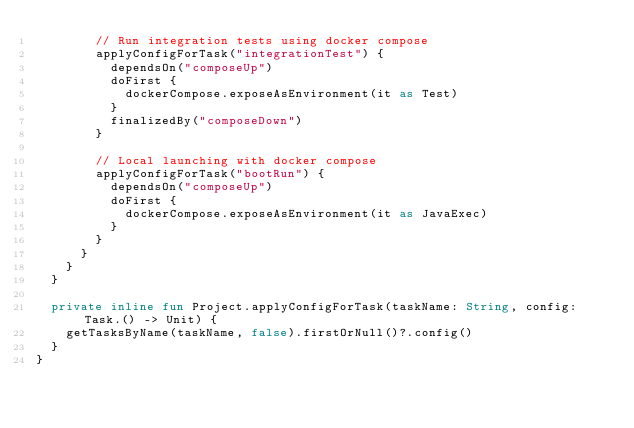Convert code to text. <code><loc_0><loc_0><loc_500><loc_500><_Kotlin_>        // Run integration tests using docker compose
        applyConfigForTask("integrationTest") {
          dependsOn("composeUp")
          doFirst {
            dockerCompose.exposeAsEnvironment(it as Test)
          }
          finalizedBy("composeDown")
        }

        // Local launching with docker compose
        applyConfigForTask("bootRun") {
          dependsOn("composeUp")
          doFirst {
            dockerCompose.exposeAsEnvironment(it as JavaExec)
          }
        }
      }
    }
  }

  private inline fun Project.applyConfigForTask(taskName: String, config: Task.() -> Unit) {
    getTasksByName(taskName, false).firstOrNull()?.config()
  }
}
</code> 